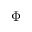<formula> <loc_0><loc_0><loc_500><loc_500>\boldsymbol \Phi</formula> 